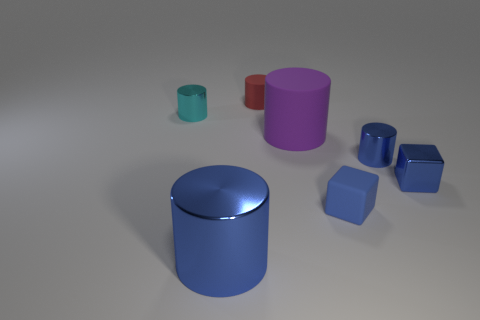There is a blue cylinder that is on the right side of the big blue cylinder; what material is it?
Ensure brevity in your answer.  Metal. There is a metal object that is to the left of the blue shiny thing that is in front of the small blue cube that is behind the matte cube; what is its color?
Your answer should be compact. Cyan. What is the color of the metallic thing that is the same size as the purple cylinder?
Provide a succinct answer. Blue. How many metallic things are either big blue cylinders or small blue things?
Your answer should be very brief. 3. The block that is the same material as the large purple object is what color?
Provide a succinct answer. Blue. What is the material of the large blue cylinder that is on the right side of the tiny object on the left side of the red matte cylinder?
Your response must be concise. Metal. What number of things are metallic cylinders in front of the small metal cube or blue objects on the right side of the tiny matte block?
Keep it short and to the point. 3. What is the size of the cylinder that is in front of the blue block that is right of the blue cylinder behind the blue metal block?
Give a very brief answer. Large. Are there an equal number of shiny objects on the left side of the red cylinder and blue cubes?
Give a very brief answer. Yes. Do the red rubber object and the blue metal thing that is on the left side of the purple matte cylinder have the same shape?
Your answer should be compact. Yes. 